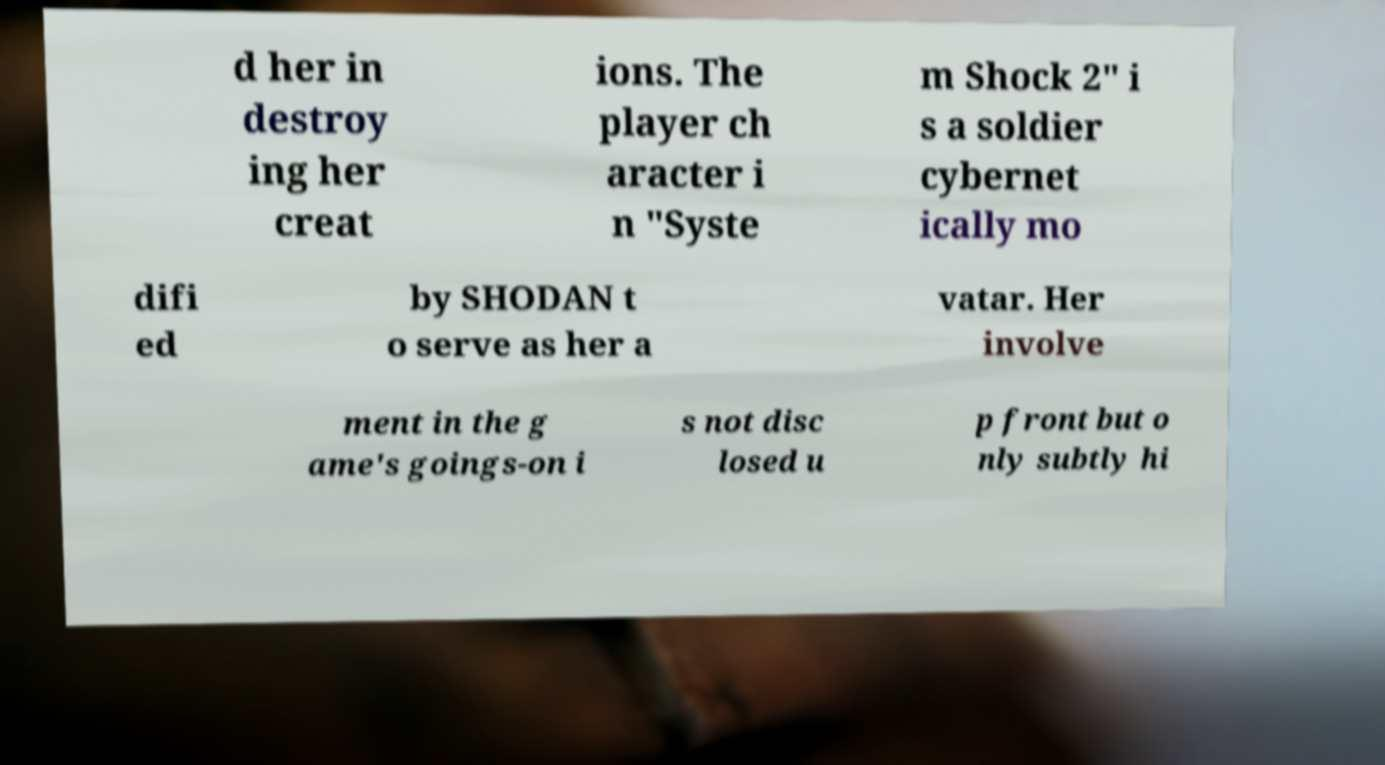Could you extract and type out the text from this image? d her in destroy ing her creat ions. The player ch aracter i n "Syste m Shock 2" i s a soldier cybernet ically mo difi ed by SHODAN t o serve as her a vatar. Her involve ment in the g ame's goings-on i s not disc losed u p front but o nly subtly hi 